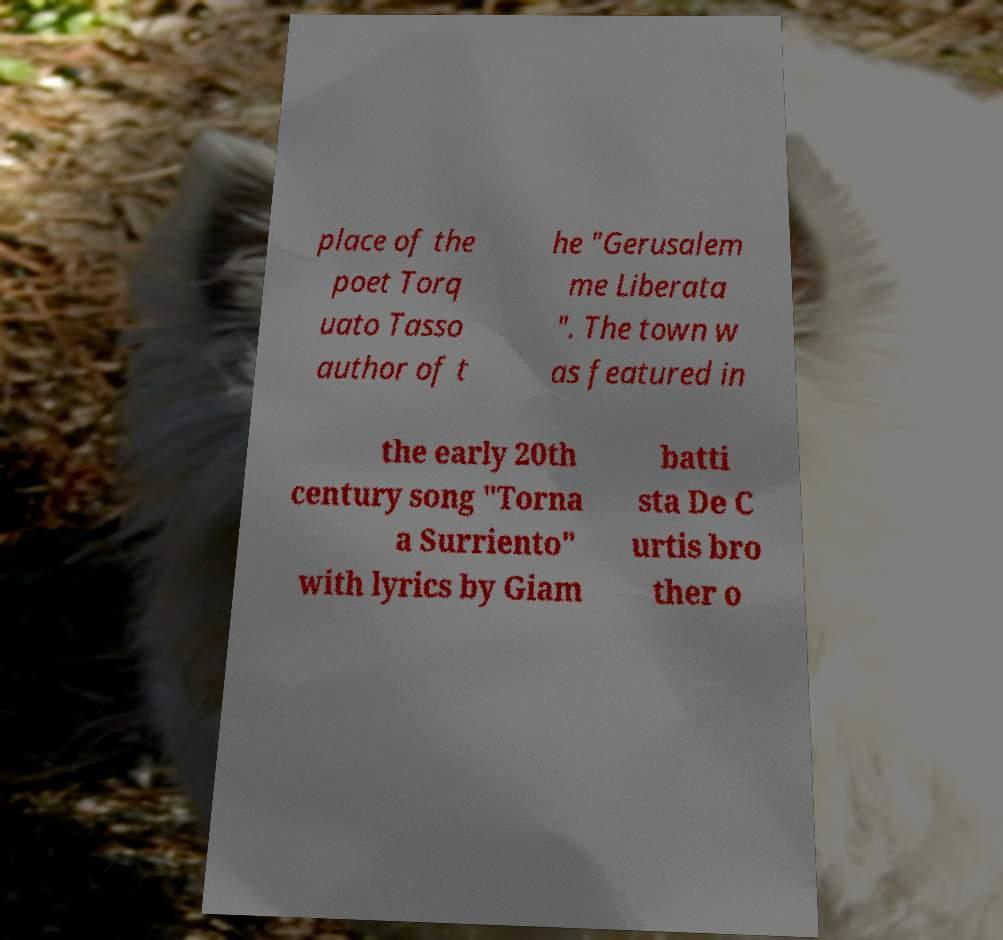I need the written content from this picture converted into text. Can you do that? place of the poet Torq uato Tasso author of t he "Gerusalem me Liberata ". The town w as featured in the early 20th century song "Torna a Surriento" with lyrics by Giam batti sta De C urtis bro ther o 